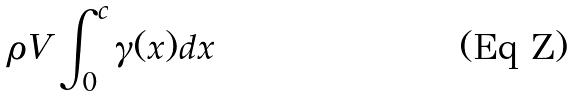Convert formula to latex. <formula><loc_0><loc_0><loc_500><loc_500>\rho V \int _ { 0 } ^ { c } \gamma ( x ) d x</formula> 